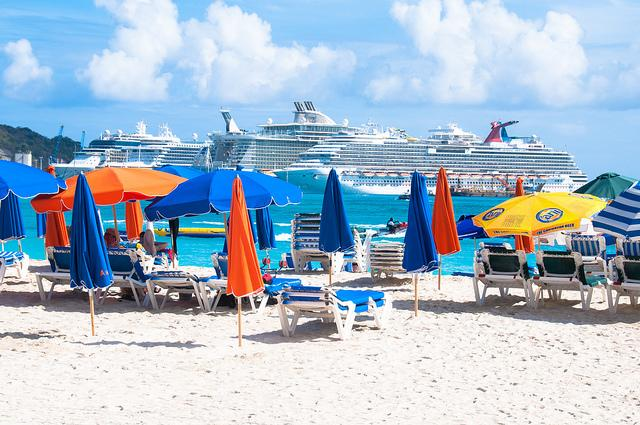What kind of ship is the one in the water? Please explain your reasoning. passenger. These type of cruise ships house many people. 